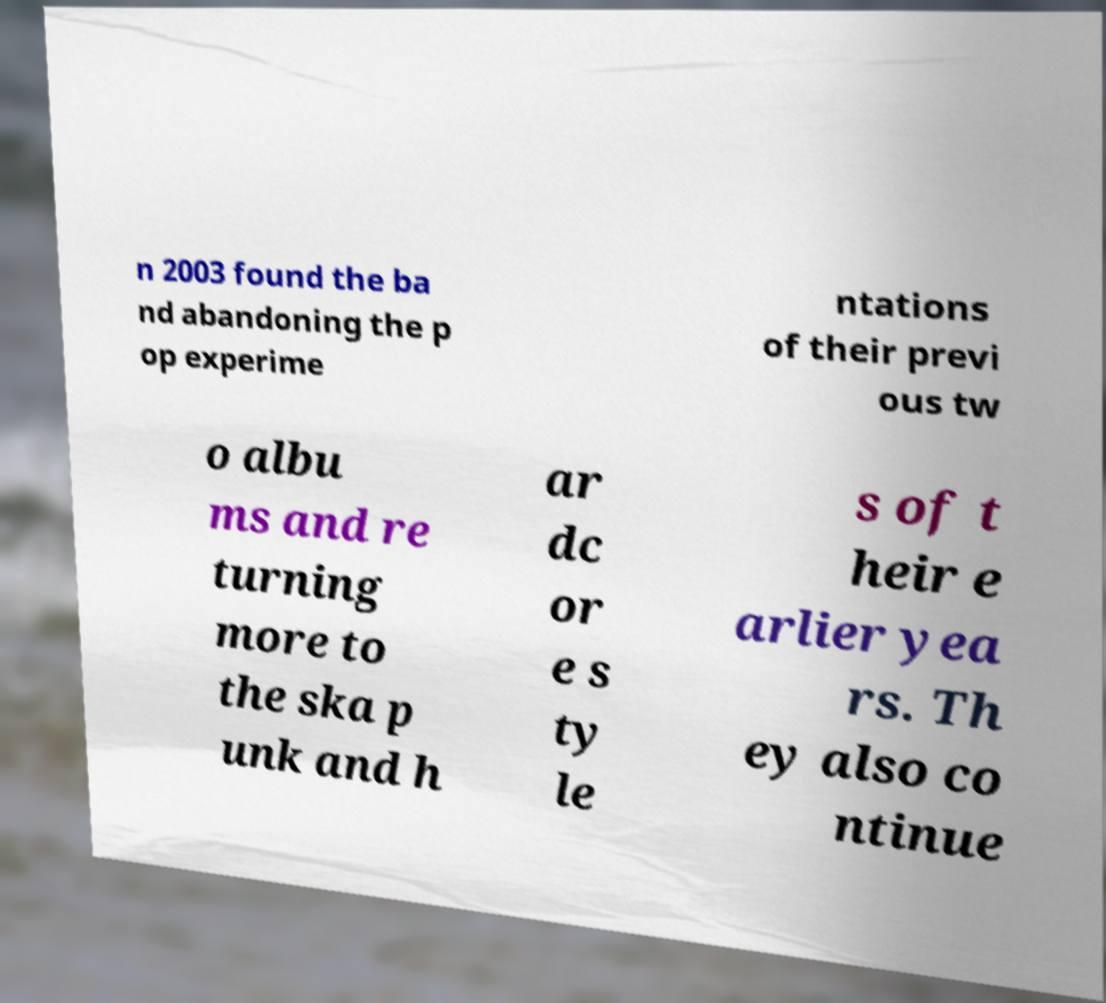Can you read and provide the text displayed in the image?This photo seems to have some interesting text. Can you extract and type it out for me? n 2003 found the ba nd abandoning the p op experime ntations of their previ ous tw o albu ms and re turning more to the ska p unk and h ar dc or e s ty le s of t heir e arlier yea rs. Th ey also co ntinue 